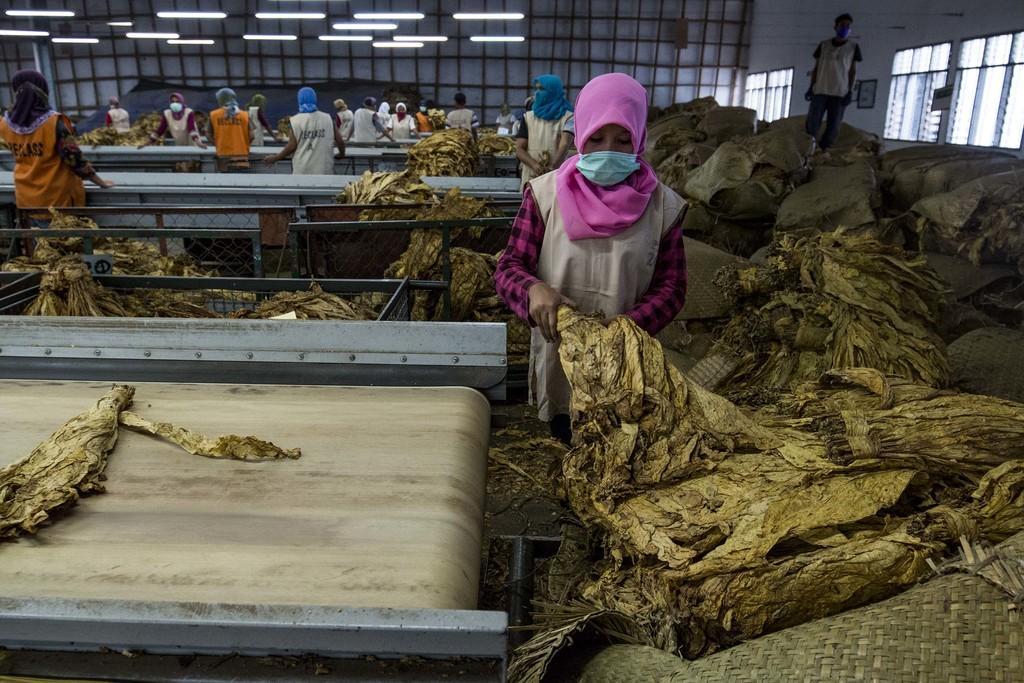Can you describe this image briefly? This picture is clicked inside. In the foreground we can see a conveyor belt and an object placed on the conveyor belt. On the right we can see the bags containing some objects and we can see the group of people standing and working. On the right there is a person standing on the bag. In the background we can see the lights, wall, metal rods and windows and some other objects. 